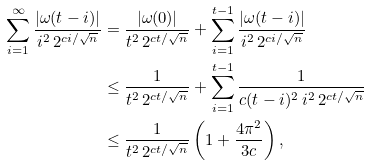Convert formula to latex. <formula><loc_0><loc_0><loc_500><loc_500>\sum _ { i = 1 } ^ { \infty } \frac { | \omega ( t - i ) | } { i ^ { 2 } \, 2 ^ { c i / \sqrt { n } } } & = \frac { | \omega ( 0 ) | } { t ^ { 2 } \, 2 ^ { c t / \sqrt { n } } } + \sum _ { i = 1 } ^ { t - 1 } \frac { | \omega ( t - i ) | } { i ^ { 2 } \, 2 ^ { c i / \sqrt { n } } } \\ & \leq \frac { 1 } { t ^ { 2 } \, 2 ^ { c t / \sqrt { n } } } + \sum _ { i = 1 } ^ { t - 1 } \frac { 1 } { c ( t - i ) ^ { 2 } \, i ^ { 2 } \, 2 ^ { c t / \sqrt { n } } } \\ & \leq \frac { 1 } { t ^ { 2 } \, 2 ^ { c t / \sqrt { n } } } \left ( 1 + \frac { 4 \pi ^ { 2 } } { 3 c } \right ) ,</formula> 